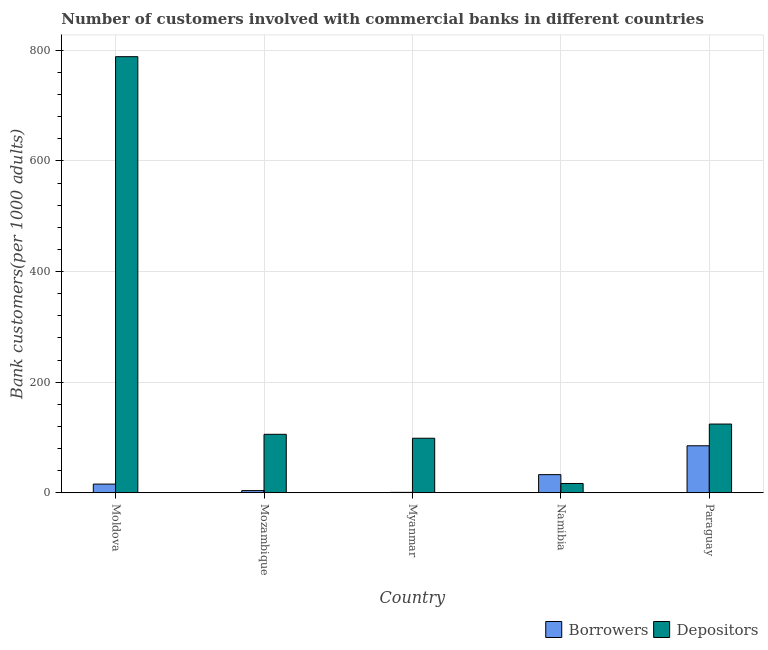Are the number of bars per tick equal to the number of legend labels?
Provide a short and direct response. Yes. How many bars are there on the 1st tick from the left?
Your response must be concise. 2. What is the label of the 5th group of bars from the left?
Offer a very short reply. Paraguay. In how many cases, is the number of bars for a given country not equal to the number of legend labels?
Ensure brevity in your answer.  0. What is the number of borrowers in Moldova?
Your response must be concise. 15.6. Across all countries, what is the maximum number of depositors?
Your response must be concise. 788.59. Across all countries, what is the minimum number of depositors?
Provide a short and direct response. 16.69. In which country was the number of depositors maximum?
Ensure brevity in your answer.  Moldova. In which country was the number of depositors minimum?
Provide a succinct answer. Namibia. What is the total number of borrowers in the graph?
Your response must be concise. 137.59. What is the difference between the number of depositors in Mozambique and that in Myanmar?
Offer a terse response. 7.11. What is the difference between the number of depositors in Paraguay and the number of borrowers in Moldova?
Offer a very short reply. 108.56. What is the average number of borrowers per country?
Make the answer very short. 27.52. What is the difference between the number of depositors and number of borrowers in Paraguay?
Your answer should be very brief. 39.29. What is the ratio of the number of depositors in Namibia to that in Paraguay?
Your answer should be very brief. 0.13. Is the number of depositors in Mozambique less than that in Namibia?
Provide a short and direct response. No. What is the difference between the highest and the second highest number of borrowers?
Keep it short and to the point. 52.18. What is the difference between the highest and the lowest number of depositors?
Make the answer very short. 771.9. In how many countries, is the number of borrowers greater than the average number of borrowers taken over all countries?
Ensure brevity in your answer.  2. Is the sum of the number of borrowers in Mozambique and Paraguay greater than the maximum number of depositors across all countries?
Your response must be concise. No. What does the 2nd bar from the left in Moldova represents?
Keep it short and to the point. Depositors. What does the 2nd bar from the right in Paraguay represents?
Ensure brevity in your answer.  Borrowers. How many bars are there?
Give a very brief answer. 10. Are all the bars in the graph horizontal?
Offer a terse response. No. What is the difference between two consecutive major ticks on the Y-axis?
Offer a very short reply. 200. Are the values on the major ticks of Y-axis written in scientific E-notation?
Your answer should be very brief. No. Where does the legend appear in the graph?
Keep it short and to the point. Bottom right. How many legend labels are there?
Keep it short and to the point. 2. How are the legend labels stacked?
Make the answer very short. Horizontal. What is the title of the graph?
Offer a very short reply. Number of customers involved with commercial banks in different countries. What is the label or title of the X-axis?
Offer a terse response. Country. What is the label or title of the Y-axis?
Your response must be concise. Bank customers(per 1000 adults). What is the Bank customers(per 1000 adults) of Borrowers in Moldova?
Ensure brevity in your answer.  15.6. What is the Bank customers(per 1000 adults) in Depositors in Moldova?
Offer a very short reply. 788.59. What is the Bank customers(per 1000 adults) in Borrowers in Mozambique?
Offer a very short reply. 3.81. What is the Bank customers(per 1000 adults) of Depositors in Mozambique?
Ensure brevity in your answer.  105.62. What is the Bank customers(per 1000 adults) in Borrowers in Myanmar?
Keep it short and to the point. 0.61. What is the Bank customers(per 1000 adults) of Depositors in Myanmar?
Offer a very short reply. 98.51. What is the Bank customers(per 1000 adults) of Borrowers in Namibia?
Provide a short and direct response. 32.69. What is the Bank customers(per 1000 adults) of Depositors in Namibia?
Your answer should be very brief. 16.69. What is the Bank customers(per 1000 adults) in Borrowers in Paraguay?
Ensure brevity in your answer.  84.87. What is the Bank customers(per 1000 adults) of Depositors in Paraguay?
Give a very brief answer. 124.16. Across all countries, what is the maximum Bank customers(per 1000 adults) of Borrowers?
Keep it short and to the point. 84.87. Across all countries, what is the maximum Bank customers(per 1000 adults) in Depositors?
Your answer should be very brief. 788.59. Across all countries, what is the minimum Bank customers(per 1000 adults) of Borrowers?
Provide a succinct answer. 0.61. Across all countries, what is the minimum Bank customers(per 1000 adults) in Depositors?
Your response must be concise. 16.69. What is the total Bank customers(per 1000 adults) of Borrowers in the graph?
Your answer should be very brief. 137.59. What is the total Bank customers(per 1000 adults) of Depositors in the graph?
Your answer should be compact. 1133.58. What is the difference between the Bank customers(per 1000 adults) in Borrowers in Moldova and that in Mozambique?
Your answer should be very brief. 11.79. What is the difference between the Bank customers(per 1000 adults) in Depositors in Moldova and that in Mozambique?
Your answer should be compact. 682.97. What is the difference between the Bank customers(per 1000 adults) of Borrowers in Moldova and that in Myanmar?
Your answer should be very brief. 14.99. What is the difference between the Bank customers(per 1000 adults) of Depositors in Moldova and that in Myanmar?
Provide a short and direct response. 690.08. What is the difference between the Bank customers(per 1000 adults) in Borrowers in Moldova and that in Namibia?
Provide a succinct answer. -17.09. What is the difference between the Bank customers(per 1000 adults) in Depositors in Moldova and that in Namibia?
Your response must be concise. 771.9. What is the difference between the Bank customers(per 1000 adults) of Borrowers in Moldova and that in Paraguay?
Give a very brief answer. -69.28. What is the difference between the Bank customers(per 1000 adults) of Depositors in Moldova and that in Paraguay?
Offer a very short reply. 664.43. What is the difference between the Bank customers(per 1000 adults) in Borrowers in Mozambique and that in Myanmar?
Provide a short and direct response. 3.2. What is the difference between the Bank customers(per 1000 adults) of Depositors in Mozambique and that in Myanmar?
Your answer should be compact. 7.11. What is the difference between the Bank customers(per 1000 adults) in Borrowers in Mozambique and that in Namibia?
Provide a succinct answer. -28.88. What is the difference between the Bank customers(per 1000 adults) in Depositors in Mozambique and that in Namibia?
Give a very brief answer. 88.93. What is the difference between the Bank customers(per 1000 adults) in Borrowers in Mozambique and that in Paraguay?
Provide a succinct answer. -81.06. What is the difference between the Bank customers(per 1000 adults) of Depositors in Mozambique and that in Paraguay?
Give a very brief answer. -18.54. What is the difference between the Bank customers(per 1000 adults) of Borrowers in Myanmar and that in Namibia?
Offer a very short reply. -32.08. What is the difference between the Bank customers(per 1000 adults) in Depositors in Myanmar and that in Namibia?
Keep it short and to the point. 81.82. What is the difference between the Bank customers(per 1000 adults) in Borrowers in Myanmar and that in Paraguay?
Offer a very short reply. -84.27. What is the difference between the Bank customers(per 1000 adults) of Depositors in Myanmar and that in Paraguay?
Your answer should be compact. -25.65. What is the difference between the Bank customers(per 1000 adults) of Borrowers in Namibia and that in Paraguay?
Provide a succinct answer. -52.18. What is the difference between the Bank customers(per 1000 adults) of Depositors in Namibia and that in Paraguay?
Keep it short and to the point. -107.47. What is the difference between the Bank customers(per 1000 adults) in Borrowers in Moldova and the Bank customers(per 1000 adults) in Depositors in Mozambique?
Make the answer very short. -90.02. What is the difference between the Bank customers(per 1000 adults) of Borrowers in Moldova and the Bank customers(per 1000 adults) of Depositors in Myanmar?
Ensure brevity in your answer.  -82.91. What is the difference between the Bank customers(per 1000 adults) in Borrowers in Moldova and the Bank customers(per 1000 adults) in Depositors in Namibia?
Keep it short and to the point. -1.09. What is the difference between the Bank customers(per 1000 adults) in Borrowers in Moldova and the Bank customers(per 1000 adults) in Depositors in Paraguay?
Provide a short and direct response. -108.56. What is the difference between the Bank customers(per 1000 adults) of Borrowers in Mozambique and the Bank customers(per 1000 adults) of Depositors in Myanmar?
Your answer should be compact. -94.7. What is the difference between the Bank customers(per 1000 adults) of Borrowers in Mozambique and the Bank customers(per 1000 adults) of Depositors in Namibia?
Provide a short and direct response. -12.88. What is the difference between the Bank customers(per 1000 adults) in Borrowers in Mozambique and the Bank customers(per 1000 adults) in Depositors in Paraguay?
Provide a succinct answer. -120.35. What is the difference between the Bank customers(per 1000 adults) of Borrowers in Myanmar and the Bank customers(per 1000 adults) of Depositors in Namibia?
Offer a terse response. -16.08. What is the difference between the Bank customers(per 1000 adults) in Borrowers in Myanmar and the Bank customers(per 1000 adults) in Depositors in Paraguay?
Your response must be concise. -123.55. What is the difference between the Bank customers(per 1000 adults) in Borrowers in Namibia and the Bank customers(per 1000 adults) in Depositors in Paraguay?
Offer a terse response. -91.47. What is the average Bank customers(per 1000 adults) of Borrowers per country?
Make the answer very short. 27.52. What is the average Bank customers(per 1000 adults) in Depositors per country?
Your response must be concise. 226.72. What is the difference between the Bank customers(per 1000 adults) in Borrowers and Bank customers(per 1000 adults) in Depositors in Moldova?
Give a very brief answer. -772.99. What is the difference between the Bank customers(per 1000 adults) in Borrowers and Bank customers(per 1000 adults) in Depositors in Mozambique?
Ensure brevity in your answer.  -101.81. What is the difference between the Bank customers(per 1000 adults) in Borrowers and Bank customers(per 1000 adults) in Depositors in Myanmar?
Give a very brief answer. -97.9. What is the difference between the Bank customers(per 1000 adults) of Borrowers and Bank customers(per 1000 adults) of Depositors in Namibia?
Keep it short and to the point. 16. What is the difference between the Bank customers(per 1000 adults) of Borrowers and Bank customers(per 1000 adults) of Depositors in Paraguay?
Offer a very short reply. -39.29. What is the ratio of the Bank customers(per 1000 adults) in Borrowers in Moldova to that in Mozambique?
Your answer should be very brief. 4.09. What is the ratio of the Bank customers(per 1000 adults) of Depositors in Moldova to that in Mozambique?
Provide a short and direct response. 7.47. What is the ratio of the Bank customers(per 1000 adults) in Borrowers in Moldova to that in Myanmar?
Your answer should be compact. 25.59. What is the ratio of the Bank customers(per 1000 adults) in Depositors in Moldova to that in Myanmar?
Offer a very short reply. 8.01. What is the ratio of the Bank customers(per 1000 adults) in Borrowers in Moldova to that in Namibia?
Ensure brevity in your answer.  0.48. What is the ratio of the Bank customers(per 1000 adults) of Depositors in Moldova to that in Namibia?
Your answer should be compact. 47.24. What is the ratio of the Bank customers(per 1000 adults) of Borrowers in Moldova to that in Paraguay?
Offer a very short reply. 0.18. What is the ratio of the Bank customers(per 1000 adults) in Depositors in Moldova to that in Paraguay?
Your response must be concise. 6.35. What is the ratio of the Bank customers(per 1000 adults) in Borrowers in Mozambique to that in Myanmar?
Your answer should be compact. 6.26. What is the ratio of the Bank customers(per 1000 adults) in Depositors in Mozambique to that in Myanmar?
Offer a very short reply. 1.07. What is the ratio of the Bank customers(per 1000 adults) of Borrowers in Mozambique to that in Namibia?
Provide a short and direct response. 0.12. What is the ratio of the Bank customers(per 1000 adults) in Depositors in Mozambique to that in Namibia?
Your answer should be very brief. 6.33. What is the ratio of the Bank customers(per 1000 adults) of Borrowers in Mozambique to that in Paraguay?
Your response must be concise. 0.04. What is the ratio of the Bank customers(per 1000 adults) in Depositors in Mozambique to that in Paraguay?
Offer a very short reply. 0.85. What is the ratio of the Bank customers(per 1000 adults) of Borrowers in Myanmar to that in Namibia?
Make the answer very short. 0.02. What is the ratio of the Bank customers(per 1000 adults) in Depositors in Myanmar to that in Namibia?
Provide a succinct answer. 5.9. What is the ratio of the Bank customers(per 1000 adults) of Borrowers in Myanmar to that in Paraguay?
Provide a short and direct response. 0.01. What is the ratio of the Bank customers(per 1000 adults) of Depositors in Myanmar to that in Paraguay?
Your answer should be very brief. 0.79. What is the ratio of the Bank customers(per 1000 adults) in Borrowers in Namibia to that in Paraguay?
Keep it short and to the point. 0.39. What is the ratio of the Bank customers(per 1000 adults) of Depositors in Namibia to that in Paraguay?
Your answer should be compact. 0.13. What is the difference between the highest and the second highest Bank customers(per 1000 adults) of Borrowers?
Your answer should be very brief. 52.18. What is the difference between the highest and the second highest Bank customers(per 1000 adults) of Depositors?
Offer a terse response. 664.43. What is the difference between the highest and the lowest Bank customers(per 1000 adults) in Borrowers?
Keep it short and to the point. 84.27. What is the difference between the highest and the lowest Bank customers(per 1000 adults) in Depositors?
Offer a terse response. 771.9. 